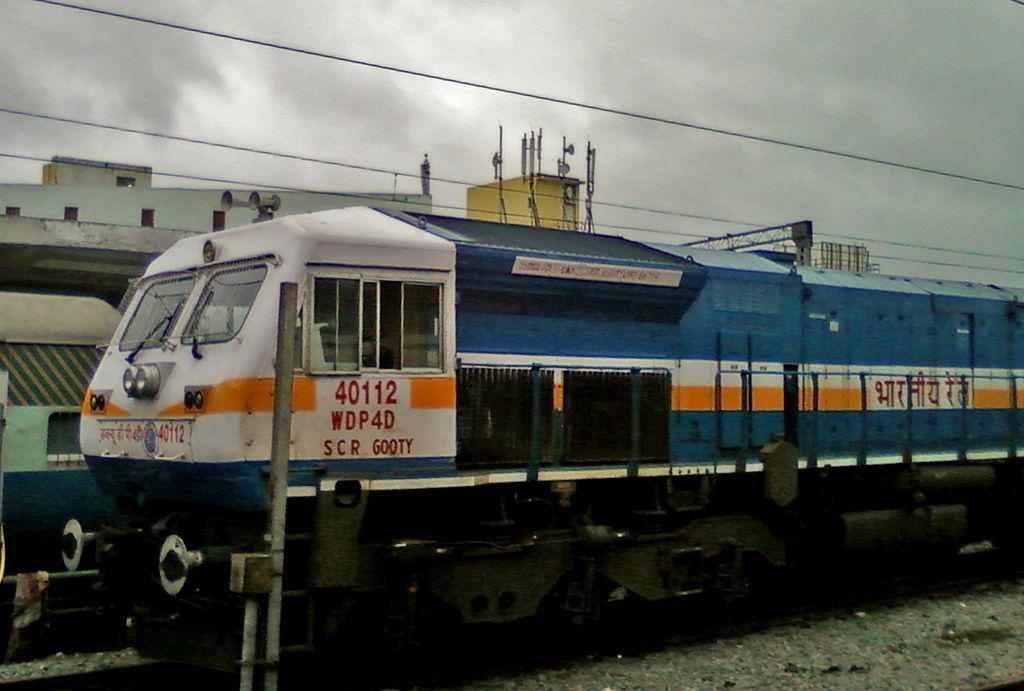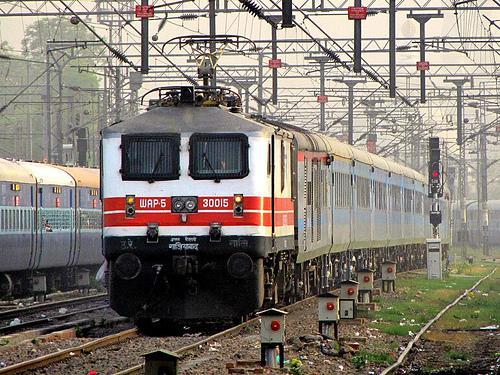The first image is the image on the left, the second image is the image on the right. Analyze the images presented: Is the assertion "All of the trains are electric." valid? Answer yes or no. Yes. 